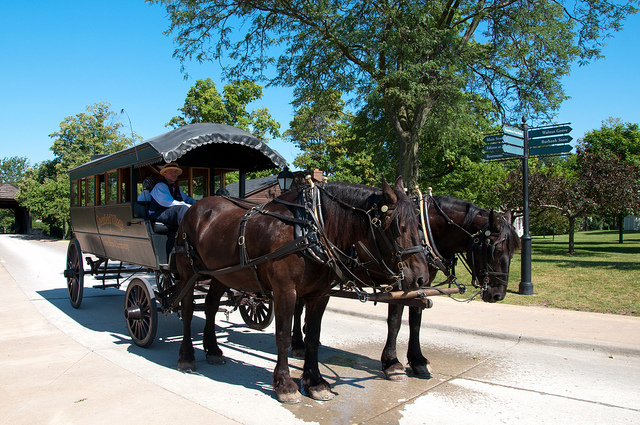<image>What marking do both horses share? I am not sure, the horses may share no marking or they may have brown hair or white hooves. What marking do both horses share? I don't know what marking both horses share. There is no visible marking in the image. 